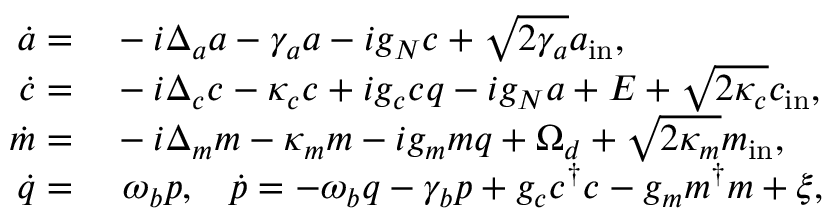<formula> <loc_0><loc_0><loc_500><loc_500>\begin{array} { r l } { \dot { a } = } & - i \Delta _ { a } a - \gamma _ { a } a - i g _ { N } c + \sqrt { 2 \gamma _ { a } } a _ { i n } , } \\ { \dot { c } = } & - i \Delta _ { c } c - \kappa _ { c } c + i g _ { c } c q - i g _ { N } a + E + \sqrt { 2 \kappa _ { c } } c _ { i n } , } \\ { \dot { m } = } & - i \Delta _ { m } m - \kappa _ { m } m - i g _ { m } m q + \Omega _ { d } + \sqrt { 2 \kappa _ { m } } m _ { i n } , } \\ { \dot { q } = } & \ \omega _ { b } p , \, \dot { p } = - \omega _ { b } q - \gamma _ { b } p + g _ { c } c ^ { \dagger } c - g _ { m } m ^ { \dagger } m + \xi , } \end{array}</formula> 